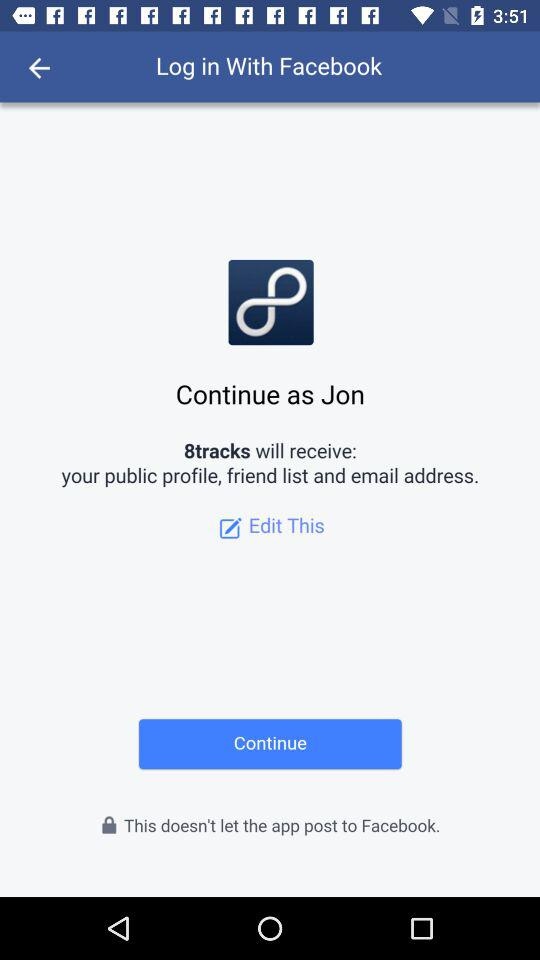What application has asked for permission? The application "8tracks" has asked for permission. 